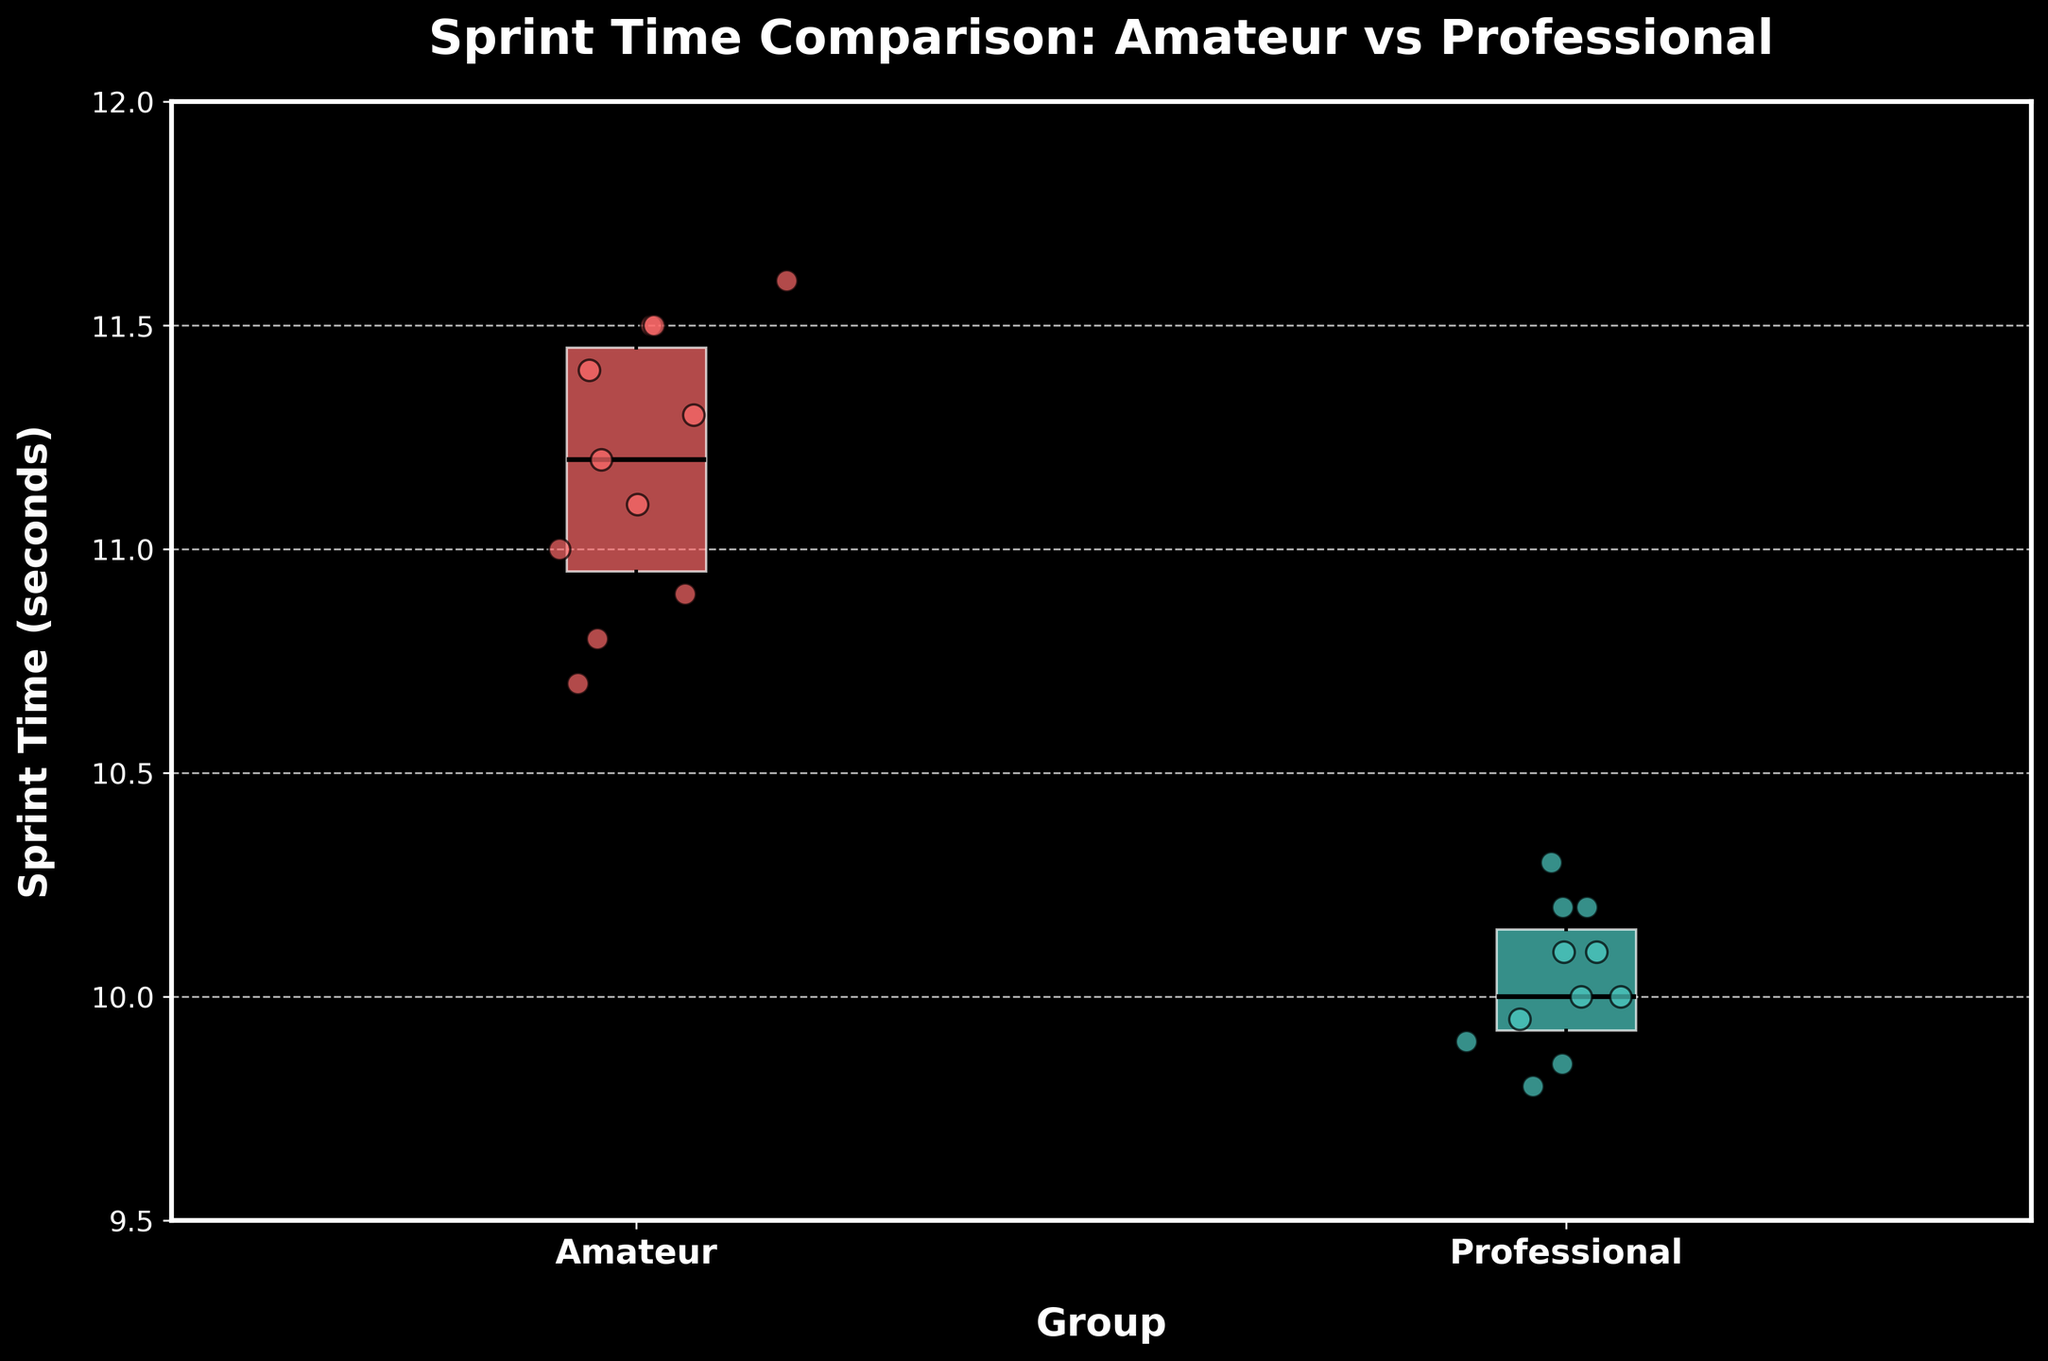What is the title of the plot? The title is located at the top of the plot, usually providing a brief description of what the plot represents. Here, the title reads "Sprint Time Comparison: Amateur vs Professional".
Answer: Sprint Time Comparison: Amateur vs Professional What does the x-axis represent? The label on the x-axis, located horizontally at the bottom beneath the scatter points and the box plots, shows "Group", indicating that it represents the different sprinting groups compared (Amateur and Professional).
Answer: Group What color represents the 'Amateur' group in the box plot? By looking at the color of the box plot for the 'Amateur' group on the x-axis, which is the first box from the left, we see that it has a light red color.
Answer: Light red What is the median sprint time for the 'Professional' group? Locate the horizontal line inside the Professional group's (second box plot) box, which marks the median. The line is at approximately 10.0 seconds.
Answer: 10.0 seconds What is the range of the sprint times for the 'Amateur' group? Find the vertical range of the box plot for the 'Amateur' group, which is from the bottom whisker to the top whisker. The minimum is approximately 10.7 and the maximum is about 11.6. Calculating the difference yields a range of 11.6 - 10.7 = 0.9 seconds.
Answer: 0.9 seconds Which group has a lower median sprint time? Compare the horizontal lines inside each box plot, representing the median. The 'Professional' group box plot median line is lower than the 'Amateur' group's median line, indicating a lower median sprint time.
Answer: Professional What is the interquartile range (IQR) of the 'Amateur' group's sprint times? The IQR is the range between the first quartile (bottom of the box) and the third quartile (top of the box). For the 'Amateur' group, this spans from approximately 11.0 to 11.4 seconds, making the IQR 11.4 - 11.0 = 0.4 seconds.
Answer: 0.4 seconds Which individual has the fastest sprint time, and what group do they belong to? Inspect the scatter points and locate the lowest point, indicating the fastest sprint time. This point is at 9.8 seconds, which belongs to Usain Bolt in the 'Professional' group.
Answer: Usain Bolt, Professional Is there any overlap in the sprint times between the 'Amateur' and 'Professional' groups? Look at the ranges of each box plot and scatter points. The highest sprint times in the 'Professional' group (10.3 seconds and above) do overlap with some of the lower sprint times in the 'Amateur' group (10.7 seconds and above).
Answer: Yes 